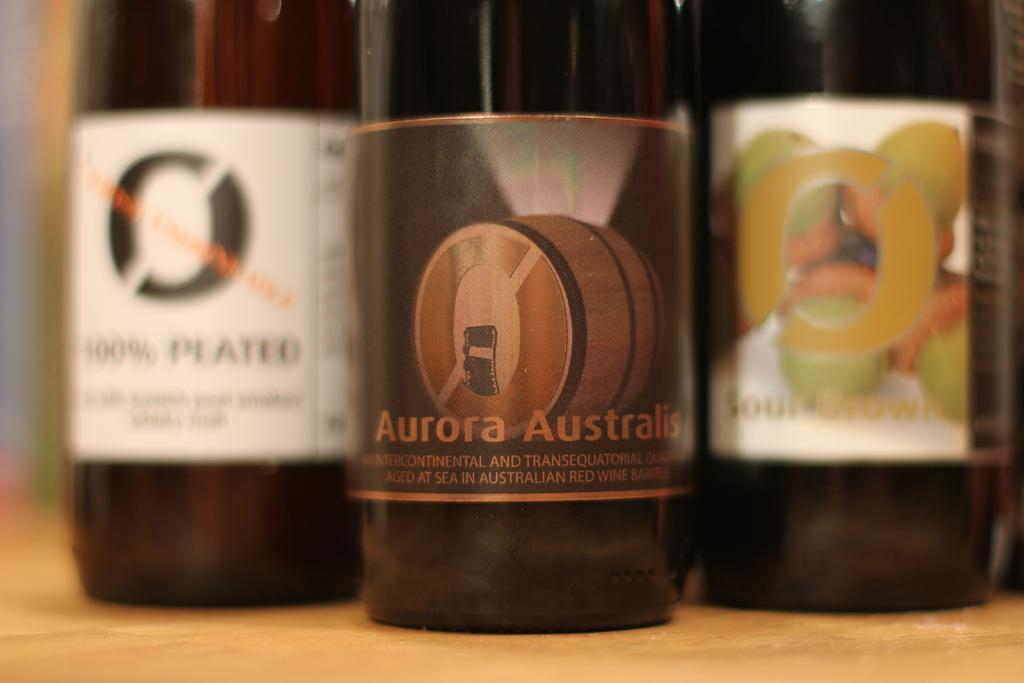Provide a one-sentence caption for the provided image. three bottles on a table, front bottle is labeled aurora australis. 